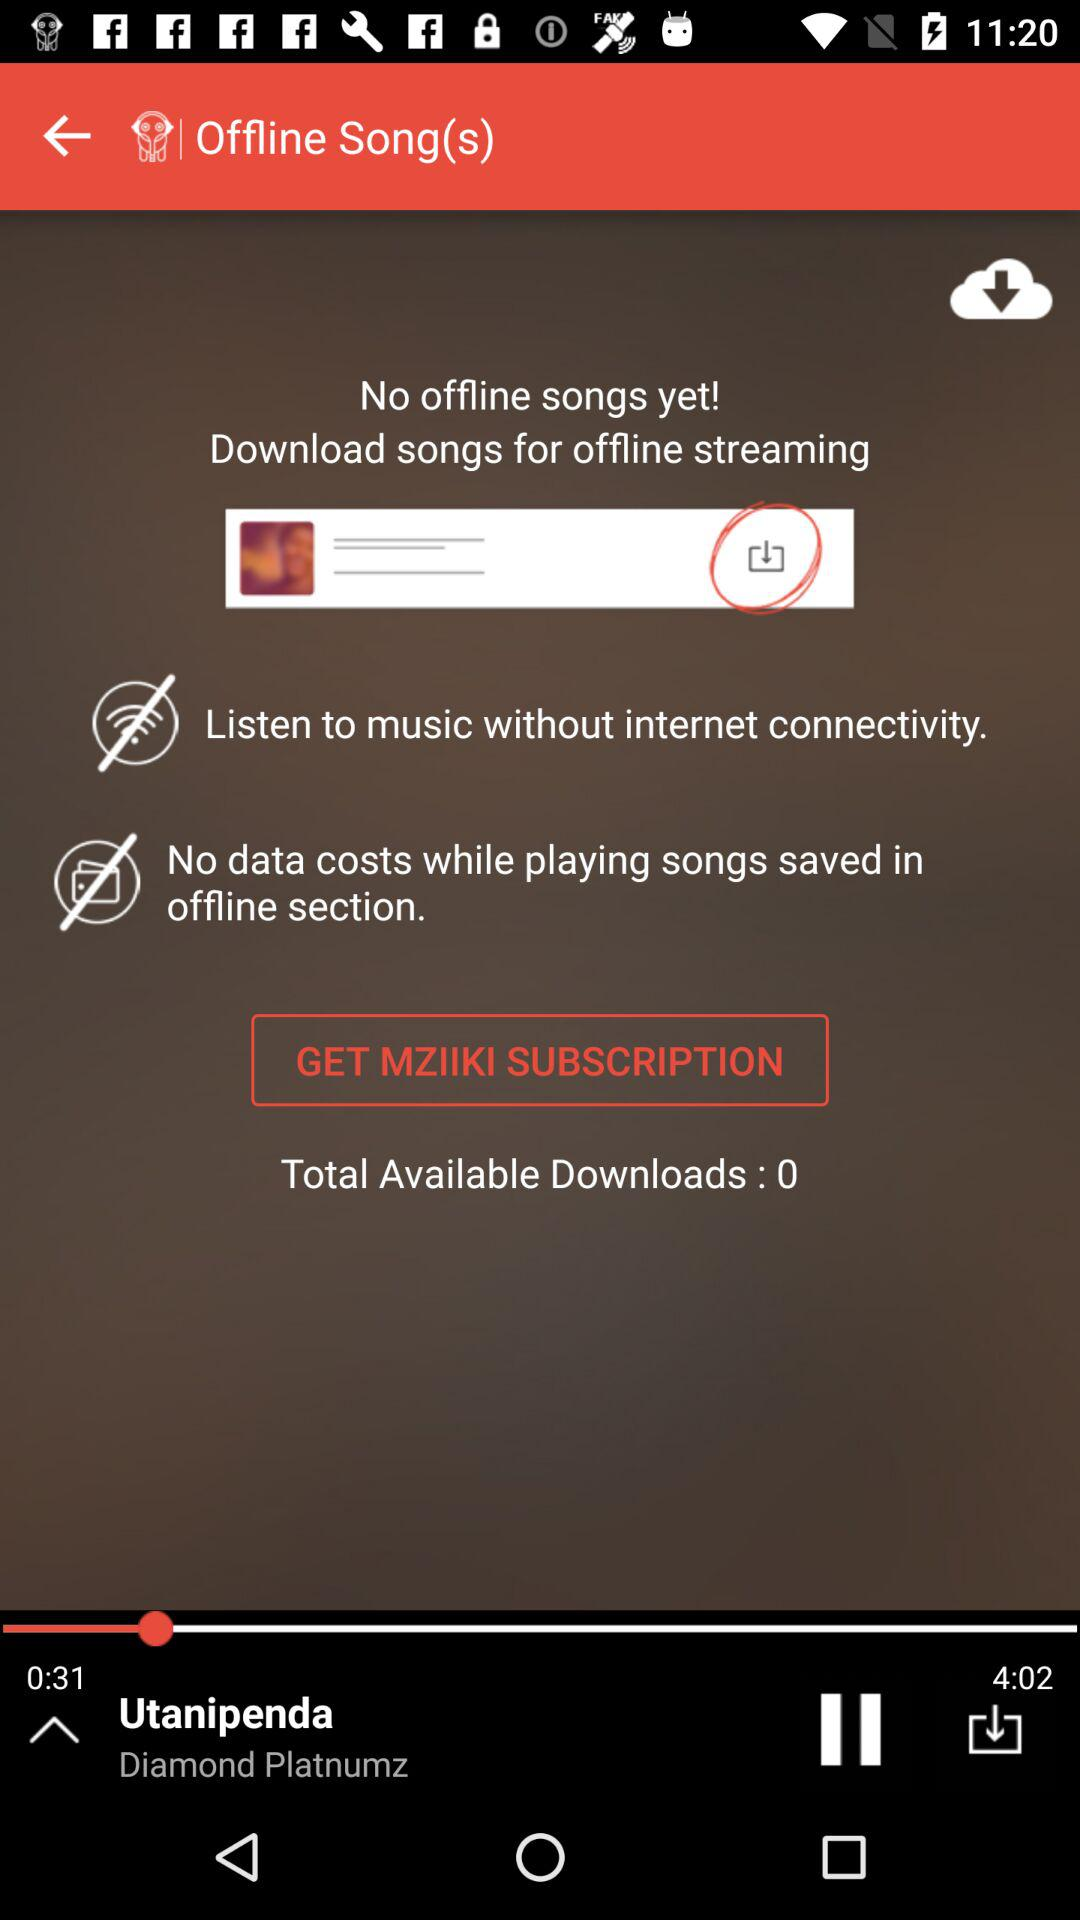How many more offline songs can be downloaded?
Answer the question using a single word or phrase. 0 